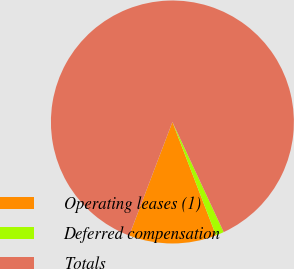Convert chart to OTSL. <chart><loc_0><loc_0><loc_500><loc_500><pie_chart><fcel>Operating leases (1)<fcel>Deferred compensation<fcel>Totals<nl><fcel>11.63%<fcel>1.1%<fcel>87.27%<nl></chart> 